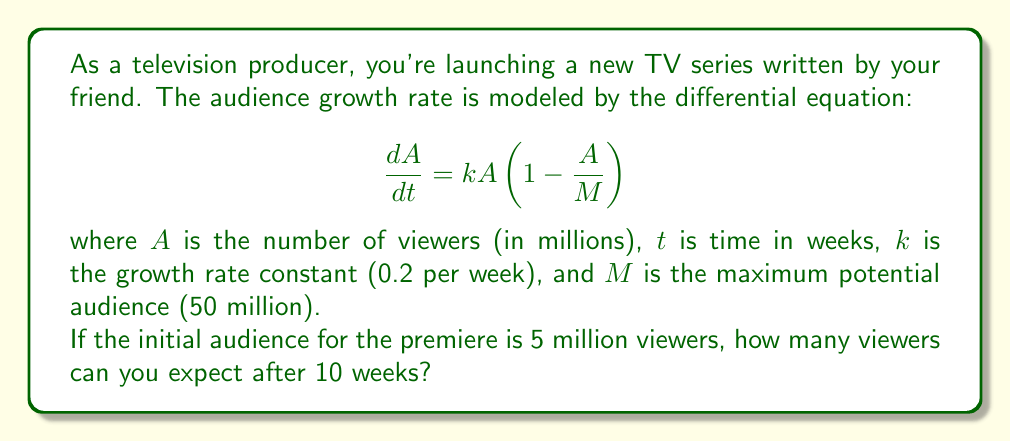Help me with this question. To solve this problem, we need to use the logistic growth model, which is a first-order differential equation. Let's approach this step-by-step:

1) The given differential equation is:
   $$\frac{dA}{dt} = kA(1 - \frac{A}{M})$$

2) This is a separable differential equation. We can solve it by separating variables and integrating:
   $$\int \frac{dA}{A(1-\frac{A}{M})} = \int k dt$$

3) The left side can be integrated using partial fractions:
   $$\int (\frac{1}{A} + \frac{1}{M-A}) dA = kt + C$$

4) After integration, we get:
   $$\ln|A| - \ln|M-A| = kt + C$$

5) Simplifying and applying the exponential function to both sides:
   $$\frac{A}{M-A} = Ce^{kt}$$

6) Solving for $A$:
   $$A = \frac{M}{1 + De^{-kt}}$$
   where $D$ is a constant determined by initial conditions.

7) Given the initial condition $A(0) = 5$, we can find $D$:
   $$5 = \frac{50}{1 + D} \implies D = 9$$

8) Therefore, our solution is:
   $$A(t) = \frac{50}{1 + 9e^{-0.2t}}$$

9) To find the number of viewers after 10 weeks, we substitute $t = 10$:
   $$A(10) = \frac{50}{1 + 9e^{-0.2(10)}} \approx 24.84$$

Therefore, after 10 weeks, you can expect approximately 24.84 million viewers.
Answer: 24.84 million viewers 